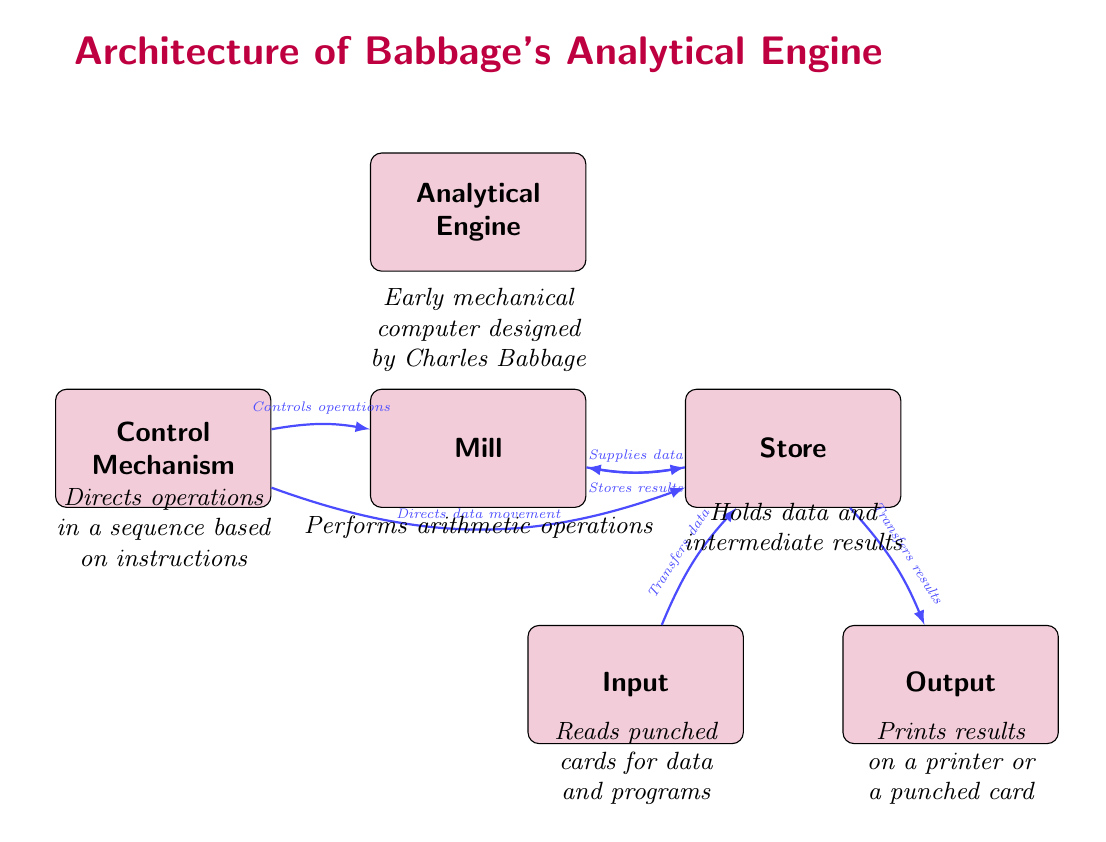What is the primary function of the Mill? The diagram indicates that the Mill performs arithmetic operations as part of the Analytical Engine.
Answer: Performs arithmetic operations How many main components are shown in the diagram? The diagram displays five main components: Analytical Engine, Mill, Store, Input, and Output. Therefore, the total count is five.
Answer: Five What does the Input node read? The Input node reads punched cards for data and programs, as described in the information under the node.
Answer: Punched cards What is the relationship between Store and Output? The diagram shows that the Store transfers results to the Output, indicating that Output receives data processed by the Store.
Answer: Transfers results What directs operations in the Analytical Engine? The Control Mechanism node is highlighted as the component that directs operations in the Analytical Engine.
Answer: Control Mechanism What is the purpose of the Store in the architecture? According to the diagram, the Store holds data and intermediate results, making it crucial for data management.
Answer: Holds data and intermediate results What does the Control Mechanism do with the Store? The diagram states that the Control Mechanism directly directs data movement to the Store, implying it manages where data is sent.
Answer: Directs data movement Which component supplies data to the Mill? The Store is indicated as supplying data to the Mill, serving as a data source for arithmetic operations.
Answer: Supplies data How does the Output display results? The Output node indicates that it prints results either on a printer or a punched card, detailing the methods of result presentation.
Answer: Prints results on a printer or a punched card 